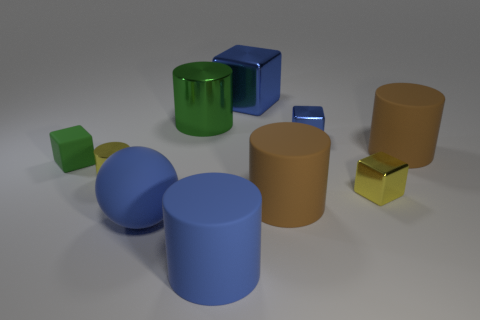There is a tiny metallic object that is in front of the small yellow metallic cylinder; is its shape the same as the big matte thing to the left of the blue cylinder?
Your answer should be very brief. No. What number of cylinders are in front of the big blue rubber cylinder?
Provide a succinct answer. 0. Does the brown cylinder behind the tiny shiny cylinder have the same material as the yellow block?
Give a very brief answer. No. What color is the big object that is the same shape as the tiny green object?
Provide a succinct answer. Blue. The green shiny object has what shape?
Keep it short and to the point. Cylinder. How many objects are small green matte cubes or blue things?
Provide a succinct answer. 5. Do the shiny cylinder that is in front of the big metallic cylinder and the thing behind the big green metallic object have the same color?
Give a very brief answer. No. What number of other things are the same shape as the green rubber object?
Your answer should be very brief. 3. Are there any small yellow metallic cubes?
Your answer should be very brief. Yes. How many things are either big purple objects or tiny objects that are on the right side of the large cube?
Provide a succinct answer. 2. 